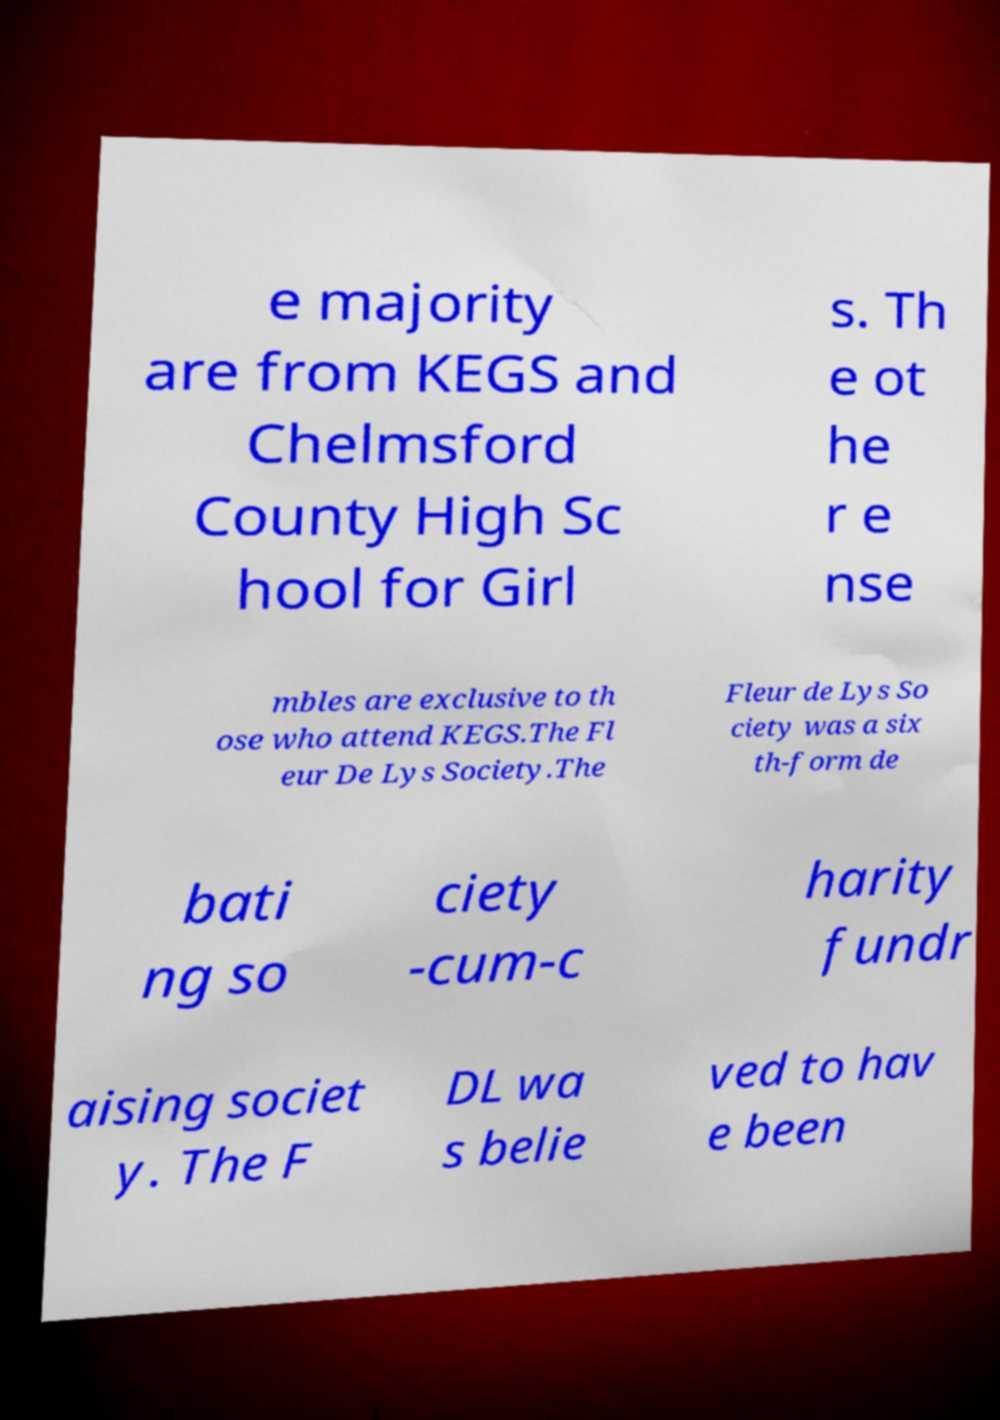I need the written content from this picture converted into text. Can you do that? e majority are from KEGS and Chelmsford County High Sc hool for Girl s. Th e ot he r e nse mbles are exclusive to th ose who attend KEGS.The Fl eur De Lys Society.The Fleur de Lys So ciety was a six th-form de bati ng so ciety -cum-c harity fundr aising societ y. The F DL wa s belie ved to hav e been 